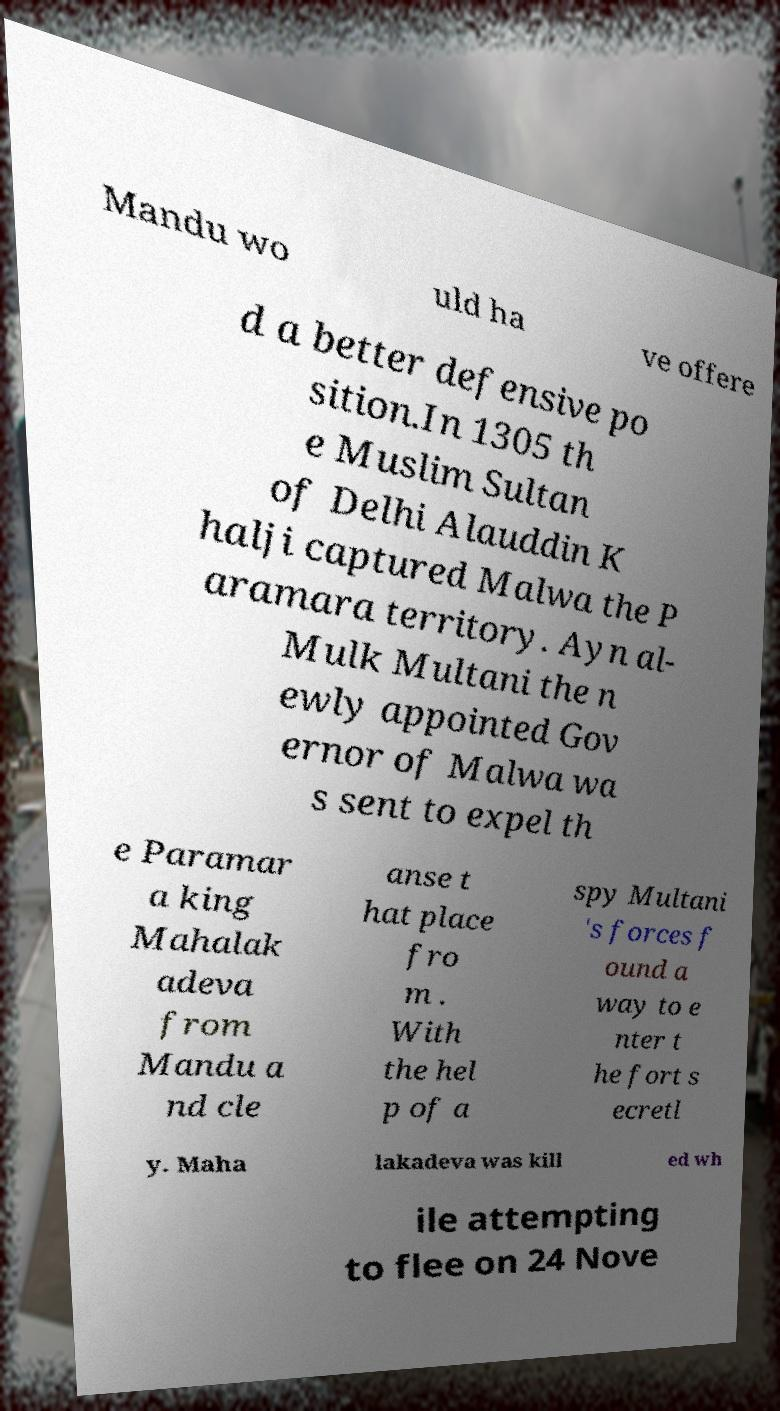Please read and relay the text visible in this image. What does it say? Mandu wo uld ha ve offere d a better defensive po sition.In 1305 th e Muslim Sultan of Delhi Alauddin K halji captured Malwa the P aramara territory. Ayn al- Mulk Multani the n ewly appointed Gov ernor of Malwa wa s sent to expel th e Paramar a king Mahalak adeva from Mandu a nd cle anse t hat place fro m . With the hel p of a spy Multani 's forces f ound a way to e nter t he fort s ecretl y. Maha lakadeva was kill ed wh ile attempting to flee on 24 Nove 